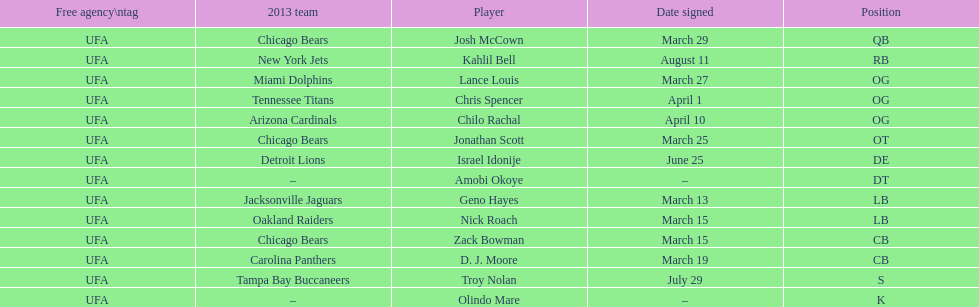The top played position according to this chart. OG. 